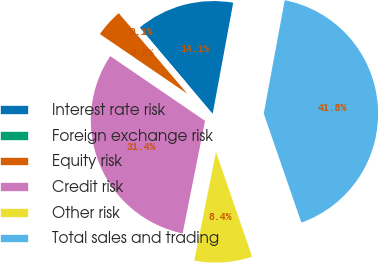Convert chart to OTSL. <chart><loc_0><loc_0><loc_500><loc_500><pie_chart><fcel>Interest rate risk<fcel>Foreign exchange risk<fcel>Equity risk<fcel>Credit risk<fcel>Other risk<fcel>Total sales and trading<nl><fcel>14.07%<fcel>0.07%<fcel>4.24%<fcel>31.4%<fcel>8.42%<fcel>41.8%<nl></chart> 